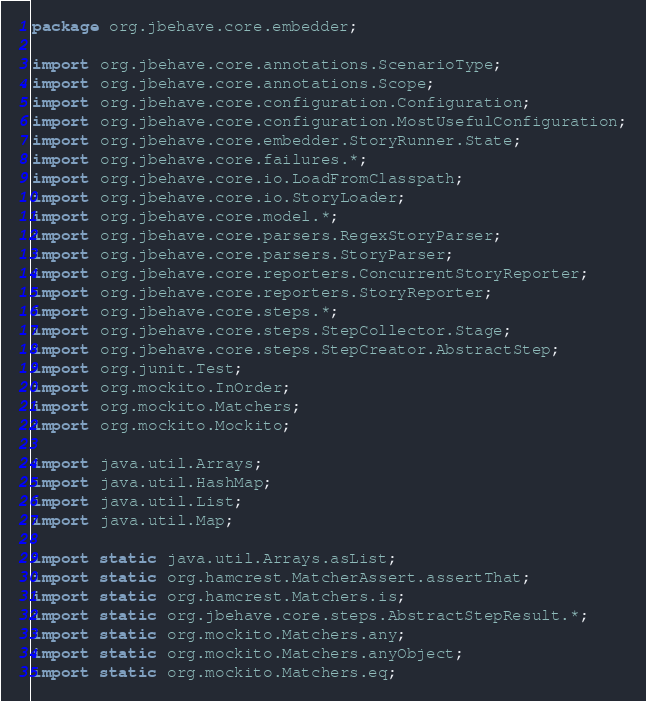<code> <loc_0><loc_0><loc_500><loc_500><_Java_>package org.jbehave.core.embedder;

import org.jbehave.core.annotations.ScenarioType;
import org.jbehave.core.annotations.Scope;
import org.jbehave.core.configuration.Configuration;
import org.jbehave.core.configuration.MostUsefulConfiguration;
import org.jbehave.core.embedder.StoryRunner.State;
import org.jbehave.core.failures.*;
import org.jbehave.core.io.LoadFromClasspath;
import org.jbehave.core.io.StoryLoader;
import org.jbehave.core.model.*;
import org.jbehave.core.parsers.RegexStoryParser;
import org.jbehave.core.parsers.StoryParser;
import org.jbehave.core.reporters.ConcurrentStoryReporter;
import org.jbehave.core.reporters.StoryReporter;
import org.jbehave.core.steps.*;
import org.jbehave.core.steps.StepCollector.Stage;
import org.jbehave.core.steps.StepCreator.AbstractStep;
import org.junit.Test;
import org.mockito.InOrder;
import org.mockito.Matchers;
import org.mockito.Mockito;

import java.util.Arrays;
import java.util.HashMap;
import java.util.List;
import java.util.Map;

import static java.util.Arrays.asList;
import static org.hamcrest.MatcherAssert.assertThat;
import static org.hamcrest.Matchers.is;
import static org.jbehave.core.steps.AbstractStepResult.*;
import static org.mockito.Matchers.any;
import static org.mockito.Matchers.anyObject;
import static org.mockito.Matchers.eq;</code> 